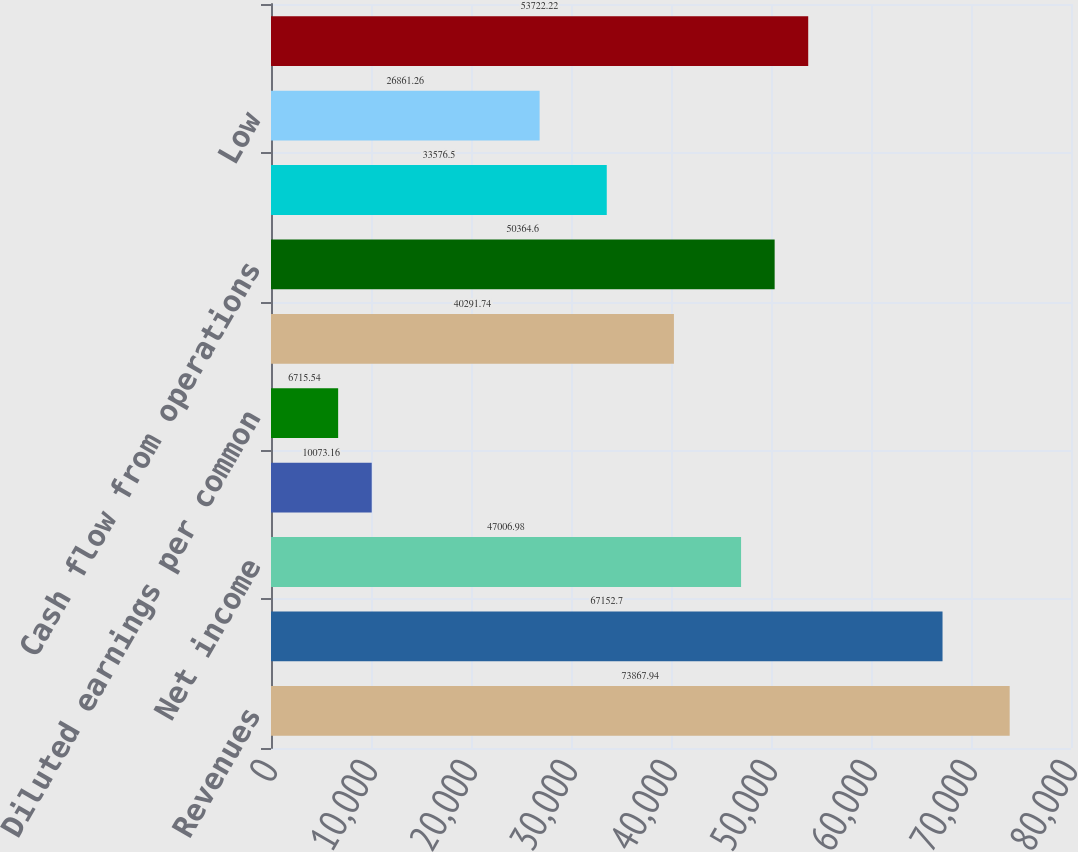<chart> <loc_0><loc_0><loc_500><loc_500><bar_chart><fcel>Revenues<fcel>Gross margin<fcel>Net income<fcel>Basic earnings per common<fcel>Diluted earnings per common<fcel>Weighted average common shares<fcel>Cash flow from operations<fcel>High<fcel>Low<fcel>Cash and equivalents<nl><fcel>73867.9<fcel>67152.7<fcel>47007<fcel>10073.2<fcel>6715.54<fcel>40291.7<fcel>50364.6<fcel>33576.5<fcel>26861.3<fcel>53722.2<nl></chart> 